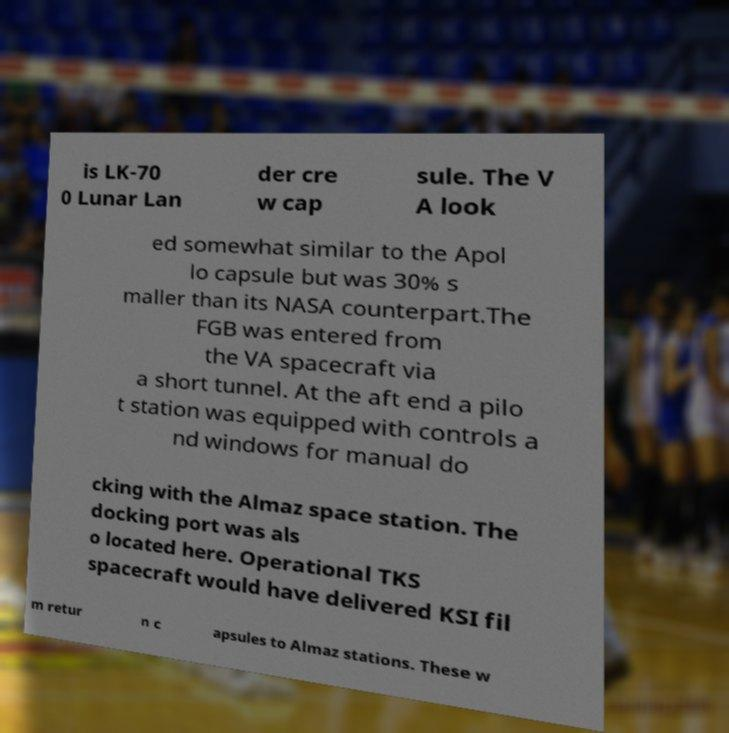For documentation purposes, I need the text within this image transcribed. Could you provide that? is LK-70 0 Lunar Lan der cre w cap sule. The V A look ed somewhat similar to the Apol lo capsule but was 30% s maller than its NASA counterpart.The FGB was entered from the VA spacecraft via a short tunnel. At the aft end a pilo t station was equipped with controls a nd windows for manual do cking with the Almaz space station. The docking port was als o located here. Operational TKS spacecraft would have delivered KSI fil m retur n c apsules to Almaz stations. These w 